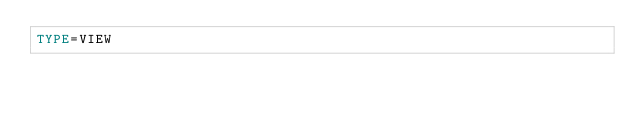<code> <loc_0><loc_0><loc_500><loc_500><_VisualBasic_>TYPE=VIEW</code> 